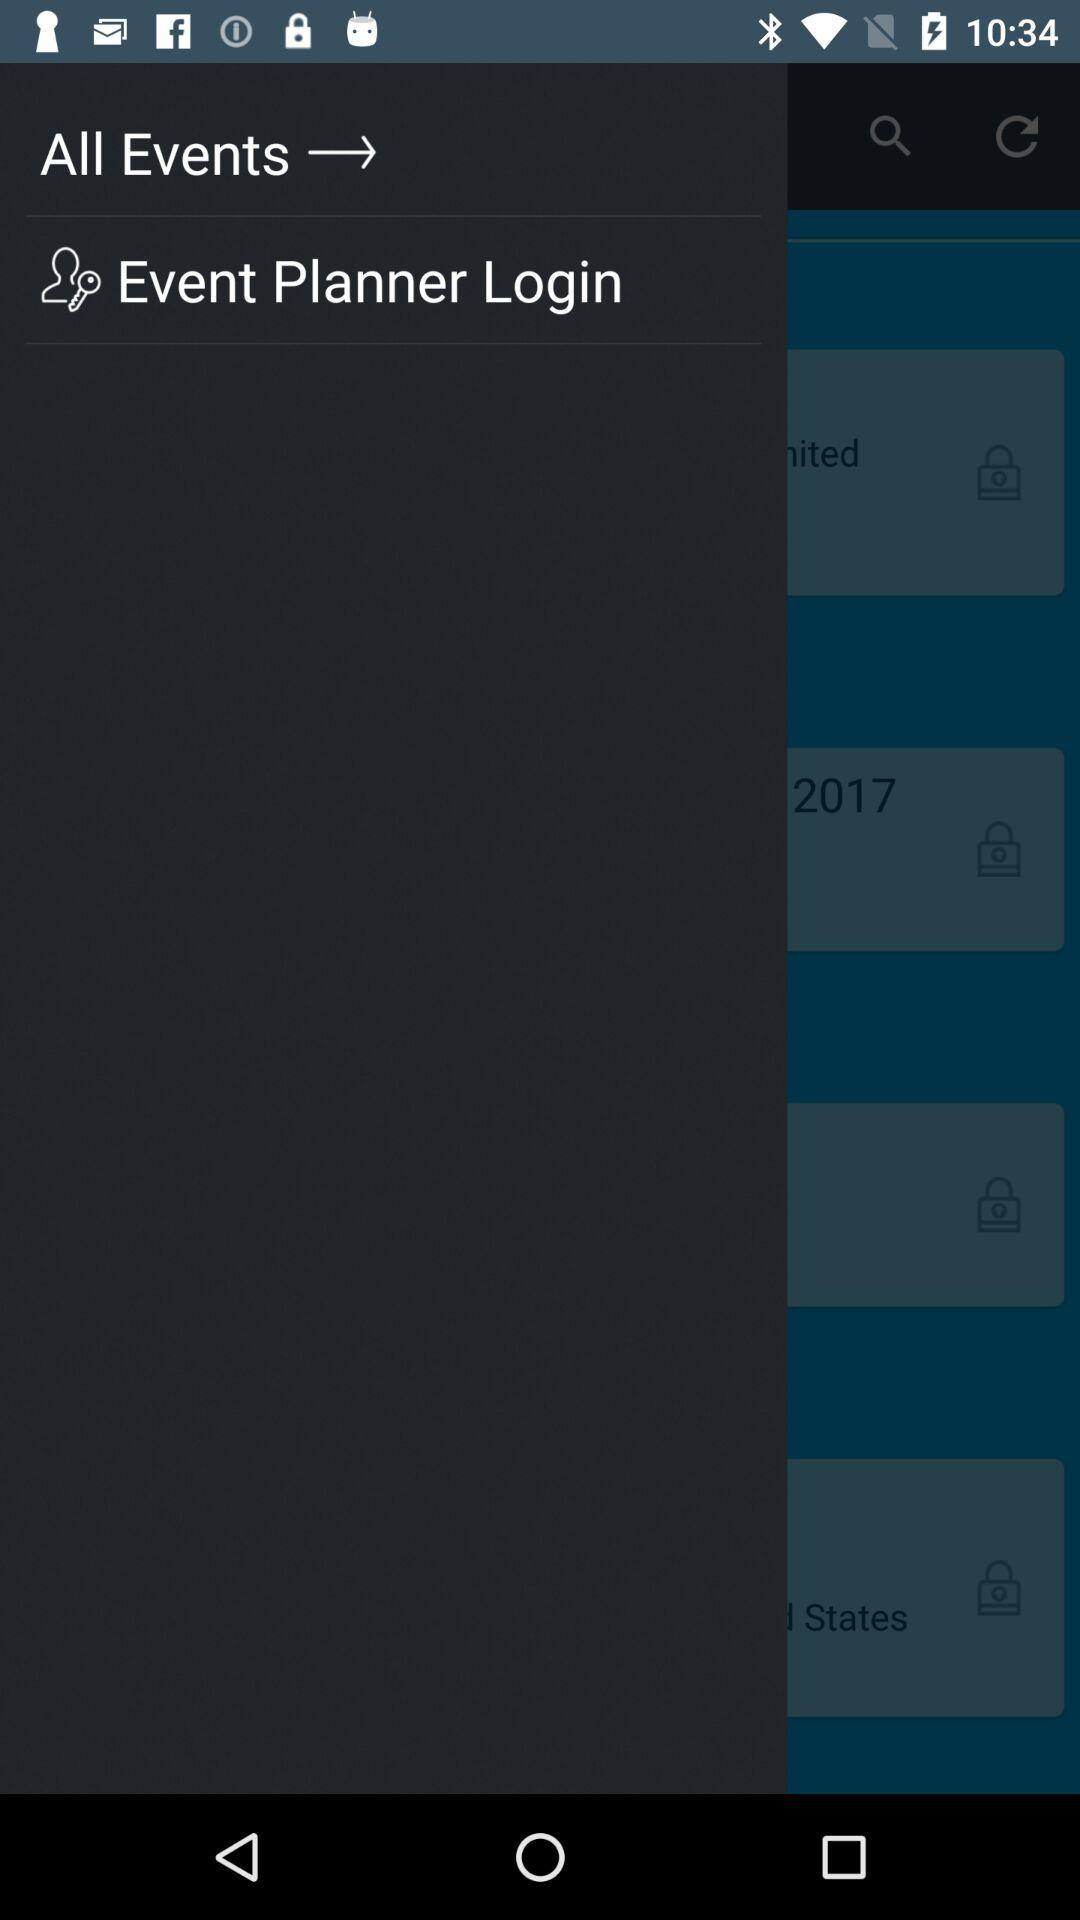How many items are locked?
Answer the question using a single word or phrase. 4 